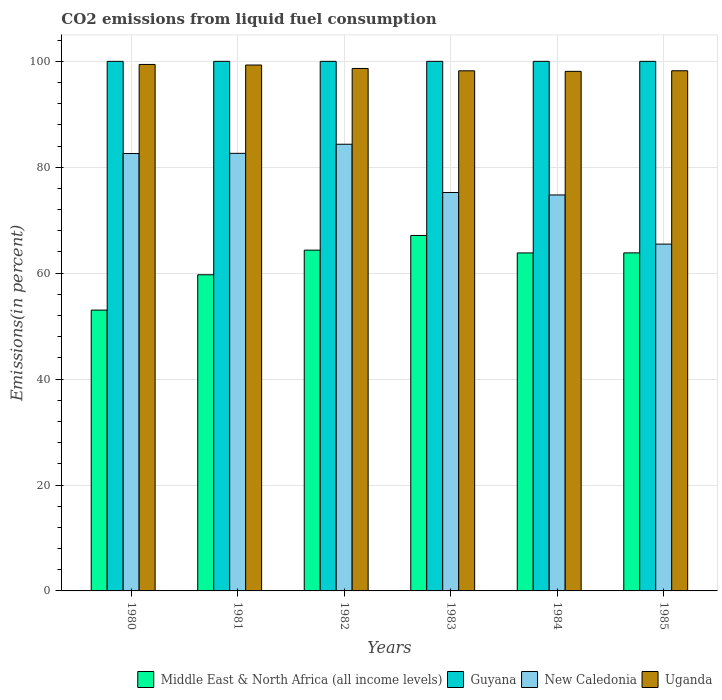Are the number of bars on each tick of the X-axis equal?
Your response must be concise. Yes. How many bars are there on the 5th tick from the left?
Offer a very short reply. 4. What is the label of the 1st group of bars from the left?
Offer a terse response. 1980. What is the total CO2 emitted in Middle East & North Africa (all income levels) in 1984?
Offer a very short reply. 63.83. Across all years, what is the maximum total CO2 emitted in Guyana?
Give a very brief answer. 100. Across all years, what is the minimum total CO2 emitted in Middle East & North Africa (all income levels)?
Offer a very short reply. 53.03. What is the total total CO2 emitted in New Caledonia in the graph?
Your response must be concise. 465.08. What is the difference between the total CO2 emitted in Uganda in 1980 and that in 1982?
Your answer should be very brief. 0.76. What is the difference between the total CO2 emitted in Uganda in 1985 and the total CO2 emitted in New Caledonia in 1980?
Make the answer very short. 15.62. What is the average total CO2 emitted in Uganda per year?
Ensure brevity in your answer.  98.66. In the year 1983, what is the difference between the total CO2 emitted in Middle East & North Africa (all income levels) and total CO2 emitted in Uganda?
Offer a very short reply. -31.09. Is the total CO2 emitted in Guyana in 1983 less than that in 1984?
Provide a succinct answer. No. What is the difference between the highest and the second highest total CO2 emitted in Middle East & North Africa (all income levels)?
Give a very brief answer. 2.77. What is the difference between the highest and the lowest total CO2 emitted in Uganda?
Provide a succinct answer. 1.3. What does the 4th bar from the left in 1983 represents?
Provide a short and direct response. Uganda. What does the 4th bar from the right in 1982 represents?
Ensure brevity in your answer.  Middle East & North Africa (all income levels). How many bars are there?
Ensure brevity in your answer.  24. What is the difference between two consecutive major ticks on the Y-axis?
Your answer should be very brief. 20. Does the graph contain any zero values?
Give a very brief answer. No. Where does the legend appear in the graph?
Provide a succinct answer. Bottom right. What is the title of the graph?
Give a very brief answer. CO2 emissions from liquid fuel consumption. What is the label or title of the Y-axis?
Ensure brevity in your answer.  Emissions(in percent). What is the Emissions(in percent) in Middle East & North Africa (all income levels) in 1980?
Ensure brevity in your answer.  53.03. What is the Emissions(in percent) of Guyana in 1980?
Make the answer very short. 100. What is the Emissions(in percent) of New Caledonia in 1980?
Provide a short and direct response. 82.6. What is the Emissions(in percent) in Uganda in 1980?
Offer a terse response. 99.42. What is the Emissions(in percent) in Middle East & North Africa (all income levels) in 1981?
Keep it short and to the point. 59.7. What is the Emissions(in percent) in Guyana in 1981?
Offer a very short reply. 100. What is the Emissions(in percent) in New Caledonia in 1981?
Your answer should be very brief. 82.63. What is the Emissions(in percent) of Uganda in 1981?
Your answer should be compact. 99.31. What is the Emissions(in percent) of Middle East & North Africa (all income levels) in 1982?
Make the answer very short. 64.35. What is the Emissions(in percent) in Guyana in 1982?
Provide a succinct answer. 100. What is the Emissions(in percent) of New Caledonia in 1982?
Ensure brevity in your answer.  84.35. What is the Emissions(in percent) of Uganda in 1982?
Your response must be concise. 98.66. What is the Emissions(in percent) of Middle East & North Africa (all income levels) in 1983?
Your answer should be compact. 67.12. What is the Emissions(in percent) in New Caledonia in 1983?
Your response must be concise. 75.24. What is the Emissions(in percent) of Uganda in 1983?
Provide a succinct answer. 98.21. What is the Emissions(in percent) in Middle East & North Africa (all income levels) in 1984?
Ensure brevity in your answer.  63.83. What is the Emissions(in percent) in Guyana in 1984?
Offer a very short reply. 100. What is the Emissions(in percent) in New Caledonia in 1984?
Your response must be concise. 74.77. What is the Emissions(in percent) of Uganda in 1984?
Keep it short and to the point. 98.11. What is the Emissions(in percent) in Middle East & North Africa (all income levels) in 1985?
Provide a short and direct response. 63.83. What is the Emissions(in percent) in New Caledonia in 1985?
Give a very brief answer. 65.49. What is the Emissions(in percent) in Uganda in 1985?
Provide a succinct answer. 98.22. Across all years, what is the maximum Emissions(in percent) in Middle East & North Africa (all income levels)?
Your answer should be compact. 67.12. Across all years, what is the maximum Emissions(in percent) of Guyana?
Your answer should be compact. 100. Across all years, what is the maximum Emissions(in percent) in New Caledonia?
Offer a terse response. 84.35. Across all years, what is the maximum Emissions(in percent) of Uganda?
Give a very brief answer. 99.42. Across all years, what is the minimum Emissions(in percent) of Middle East & North Africa (all income levels)?
Make the answer very short. 53.03. Across all years, what is the minimum Emissions(in percent) in New Caledonia?
Ensure brevity in your answer.  65.49. Across all years, what is the minimum Emissions(in percent) of Uganda?
Provide a short and direct response. 98.11. What is the total Emissions(in percent) of Middle East & North Africa (all income levels) in the graph?
Make the answer very short. 371.86. What is the total Emissions(in percent) of Guyana in the graph?
Keep it short and to the point. 600. What is the total Emissions(in percent) of New Caledonia in the graph?
Your answer should be very brief. 465.08. What is the total Emissions(in percent) in Uganda in the graph?
Your answer should be very brief. 591.93. What is the difference between the Emissions(in percent) in Middle East & North Africa (all income levels) in 1980 and that in 1981?
Provide a short and direct response. -6.68. What is the difference between the Emissions(in percent) of Guyana in 1980 and that in 1981?
Your response must be concise. 0. What is the difference between the Emissions(in percent) of New Caledonia in 1980 and that in 1981?
Your answer should be compact. -0.03. What is the difference between the Emissions(in percent) of Uganda in 1980 and that in 1981?
Your response must be concise. 0.11. What is the difference between the Emissions(in percent) in Middle East & North Africa (all income levels) in 1980 and that in 1982?
Make the answer very short. -11.32. What is the difference between the Emissions(in percent) in New Caledonia in 1980 and that in 1982?
Provide a short and direct response. -1.75. What is the difference between the Emissions(in percent) of Uganda in 1980 and that in 1982?
Your response must be concise. 0.76. What is the difference between the Emissions(in percent) in Middle East & North Africa (all income levels) in 1980 and that in 1983?
Offer a very short reply. -14.09. What is the difference between the Emissions(in percent) in New Caledonia in 1980 and that in 1983?
Your answer should be very brief. 7.36. What is the difference between the Emissions(in percent) in Uganda in 1980 and that in 1983?
Keep it short and to the point. 1.2. What is the difference between the Emissions(in percent) in Middle East & North Africa (all income levels) in 1980 and that in 1984?
Offer a very short reply. -10.8. What is the difference between the Emissions(in percent) in Guyana in 1980 and that in 1984?
Your answer should be compact. 0. What is the difference between the Emissions(in percent) of New Caledonia in 1980 and that in 1984?
Give a very brief answer. 7.83. What is the difference between the Emissions(in percent) in Uganda in 1980 and that in 1984?
Your answer should be compact. 1.3. What is the difference between the Emissions(in percent) of Middle East & North Africa (all income levels) in 1980 and that in 1985?
Provide a succinct answer. -10.81. What is the difference between the Emissions(in percent) of New Caledonia in 1980 and that in 1985?
Your answer should be compact. 17.11. What is the difference between the Emissions(in percent) of Uganda in 1980 and that in 1985?
Your answer should be very brief. 1.19. What is the difference between the Emissions(in percent) in Middle East & North Africa (all income levels) in 1981 and that in 1982?
Offer a terse response. -4.65. What is the difference between the Emissions(in percent) in Guyana in 1981 and that in 1982?
Your response must be concise. 0. What is the difference between the Emissions(in percent) of New Caledonia in 1981 and that in 1982?
Keep it short and to the point. -1.72. What is the difference between the Emissions(in percent) in Uganda in 1981 and that in 1982?
Your response must be concise. 0.65. What is the difference between the Emissions(in percent) in Middle East & North Africa (all income levels) in 1981 and that in 1983?
Your answer should be very brief. -7.42. What is the difference between the Emissions(in percent) in New Caledonia in 1981 and that in 1983?
Your response must be concise. 7.39. What is the difference between the Emissions(in percent) of Uganda in 1981 and that in 1983?
Your answer should be very brief. 1.09. What is the difference between the Emissions(in percent) of Middle East & North Africa (all income levels) in 1981 and that in 1984?
Offer a very short reply. -4.12. What is the difference between the Emissions(in percent) in Guyana in 1981 and that in 1984?
Your response must be concise. 0. What is the difference between the Emissions(in percent) in New Caledonia in 1981 and that in 1984?
Your answer should be very brief. 7.86. What is the difference between the Emissions(in percent) in Uganda in 1981 and that in 1984?
Give a very brief answer. 1.19. What is the difference between the Emissions(in percent) in Middle East & North Africa (all income levels) in 1981 and that in 1985?
Provide a succinct answer. -4.13. What is the difference between the Emissions(in percent) in New Caledonia in 1981 and that in 1985?
Give a very brief answer. 17.14. What is the difference between the Emissions(in percent) in Uganda in 1981 and that in 1985?
Make the answer very short. 1.08. What is the difference between the Emissions(in percent) of Middle East & North Africa (all income levels) in 1982 and that in 1983?
Provide a short and direct response. -2.77. What is the difference between the Emissions(in percent) of New Caledonia in 1982 and that in 1983?
Make the answer very short. 9.11. What is the difference between the Emissions(in percent) in Uganda in 1982 and that in 1983?
Your answer should be very brief. 0.44. What is the difference between the Emissions(in percent) of Middle East & North Africa (all income levels) in 1982 and that in 1984?
Provide a short and direct response. 0.52. What is the difference between the Emissions(in percent) in Guyana in 1982 and that in 1984?
Offer a very short reply. 0. What is the difference between the Emissions(in percent) in New Caledonia in 1982 and that in 1984?
Your response must be concise. 9.58. What is the difference between the Emissions(in percent) of Uganda in 1982 and that in 1984?
Give a very brief answer. 0.54. What is the difference between the Emissions(in percent) in Middle East & North Africa (all income levels) in 1982 and that in 1985?
Your answer should be compact. 0.52. What is the difference between the Emissions(in percent) in Guyana in 1982 and that in 1985?
Offer a very short reply. 0. What is the difference between the Emissions(in percent) in New Caledonia in 1982 and that in 1985?
Ensure brevity in your answer.  18.86. What is the difference between the Emissions(in percent) of Uganda in 1982 and that in 1985?
Your response must be concise. 0.43. What is the difference between the Emissions(in percent) of Middle East & North Africa (all income levels) in 1983 and that in 1984?
Your answer should be compact. 3.3. What is the difference between the Emissions(in percent) of New Caledonia in 1983 and that in 1984?
Keep it short and to the point. 0.47. What is the difference between the Emissions(in percent) of Uganda in 1983 and that in 1984?
Your response must be concise. 0.1. What is the difference between the Emissions(in percent) of Middle East & North Africa (all income levels) in 1983 and that in 1985?
Provide a short and direct response. 3.29. What is the difference between the Emissions(in percent) of New Caledonia in 1983 and that in 1985?
Offer a very short reply. 9.75. What is the difference between the Emissions(in percent) of Uganda in 1983 and that in 1985?
Make the answer very short. -0.01. What is the difference between the Emissions(in percent) in Middle East & North Africa (all income levels) in 1984 and that in 1985?
Your answer should be very brief. -0.01. What is the difference between the Emissions(in percent) of New Caledonia in 1984 and that in 1985?
Provide a short and direct response. 9.28. What is the difference between the Emissions(in percent) in Uganda in 1984 and that in 1985?
Offer a very short reply. -0.11. What is the difference between the Emissions(in percent) in Middle East & North Africa (all income levels) in 1980 and the Emissions(in percent) in Guyana in 1981?
Ensure brevity in your answer.  -46.97. What is the difference between the Emissions(in percent) of Middle East & North Africa (all income levels) in 1980 and the Emissions(in percent) of New Caledonia in 1981?
Give a very brief answer. -29.6. What is the difference between the Emissions(in percent) of Middle East & North Africa (all income levels) in 1980 and the Emissions(in percent) of Uganda in 1981?
Offer a very short reply. -46.28. What is the difference between the Emissions(in percent) in Guyana in 1980 and the Emissions(in percent) in New Caledonia in 1981?
Provide a short and direct response. 17.37. What is the difference between the Emissions(in percent) of Guyana in 1980 and the Emissions(in percent) of Uganda in 1981?
Provide a succinct answer. 0.69. What is the difference between the Emissions(in percent) in New Caledonia in 1980 and the Emissions(in percent) in Uganda in 1981?
Offer a very short reply. -16.7. What is the difference between the Emissions(in percent) of Middle East & North Africa (all income levels) in 1980 and the Emissions(in percent) of Guyana in 1982?
Ensure brevity in your answer.  -46.97. What is the difference between the Emissions(in percent) of Middle East & North Africa (all income levels) in 1980 and the Emissions(in percent) of New Caledonia in 1982?
Your response must be concise. -31.32. What is the difference between the Emissions(in percent) in Middle East & North Africa (all income levels) in 1980 and the Emissions(in percent) in Uganda in 1982?
Offer a terse response. -45.63. What is the difference between the Emissions(in percent) in Guyana in 1980 and the Emissions(in percent) in New Caledonia in 1982?
Offer a very short reply. 15.65. What is the difference between the Emissions(in percent) of Guyana in 1980 and the Emissions(in percent) of Uganda in 1982?
Offer a very short reply. 1.34. What is the difference between the Emissions(in percent) in New Caledonia in 1980 and the Emissions(in percent) in Uganda in 1982?
Offer a very short reply. -16.06. What is the difference between the Emissions(in percent) in Middle East & North Africa (all income levels) in 1980 and the Emissions(in percent) in Guyana in 1983?
Keep it short and to the point. -46.97. What is the difference between the Emissions(in percent) of Middle East & North Africa (all income levels) in 1980 and the Emissions(in percent) of New Caledonia in 1983?
Your answer should be very brief. -22.21. What is the difference between the Emissions(in percent) in Middle East & North Africa (all income levels) in 1980 and the Emissions(in percent) in Uganda in 1983?
Make the answer very short. -45.19. What is the difference between the Emissions(in percent) in Guyana in 1980 and the Emissions(in percent) in New Caledonia in 1983?
Offer a very short reply. 24.76. What is the difference between the Emissions(in percent) in Guyana in 1980 and the Emissions(in percent) in Uganda in 1983?
Offer a terse response. 1.79. What is the difference between the Emissions(in percent) in New Caledonia in 1980 and the Emissions(in percent) in Uganda in 1983?
Your response must be concise. -15.61. What is the difference between the Emissions(in percent) of Middle East & North Africa (all income levels) in 1980 and the Emissions(in percent) of Guyana in 1984?
Your answer should be compact. -46.97. What is the difference between the Emissions(in percent) in Middle East & North Africa (all income levels) in 1980 and the Emissions(in percent) in New Caledonia in 1984?
Provide a succinct answer. -21.75. What is the difference between the Emissions(in percent) of Middle East & North Africa (all income levels) in 1980 and the Emissions(in percent) of Uganda in 1984?
Provide a succinct answer. -45.09. What is the difference between the Emissions(in percent) of Guyana in 1980 and the Emissions(in percent) of New Caledonia in 1984?
Offer a very short reply. 25.23. What is the difference between the Emissions(in percent) of Guyana in 1980 and the Emissions(in percent) of Uganda in 1984?
Provide a succinct answer. 1.89. What is the difference between the Emissions(in percent) of New Caledonia in 1980 and the Emissions(in percent) of Uganda in 1984?
Your response must be concise. -15.51. What is the difference between the Emissions(in percent) in Middle East & North Africa (all income levels) in 1980 and the Emissions(in percent) in Guyana in 1985?
Provide a short and direct response. -46.97. What is the difference between the Emissions(in percent) in Middle East & North Africa (all income levels) in 1980 and the Emissions(in percent) in New Caledonia in 1985?
Offer a terse response. -12.46. What is the difference between the Emissions(in percent) of Middle East & North Africa (all income levels) in 1980 and the Emissions(in percent) of Uganda in 1985?
Your answer should be compact. -45.2. What is the difference between the Emissions(in percent) of Guyana in 1980 and the Emissions(in percent) of New Caledonia in 1985?
Keep it short and to the point. 34.51. What is the difference between the Emissions(in percent) in Guyana in 1980 and the Emissions(in percent) in Uganda in 1985?
Make the answer very short. 1.78. What is the difference between the Emissions(in percent) of New Caledonia in 1980 and the Emissions(in percent) of Uganda in 1985?
Your answer should be very brief. -15.62. What is the difference between the Emissions(in percent) in Middle East & North Africa (all income levels) in 1981 and the Emissions(in percent) in Guyana in 1982?
Offer a very short reply. -40.3. What is the difference between the Emissions(in percent) of Middle East & North Africa (all income levels) in 1981 and the Emissions(in percent) of New Caledonia in 1982?
Your answer should be compact. -24.64. What is the difference between the Emissions(in percent) of Middle East & North Africa (all income levels) in 1981 and the Emissions(in percent) of Uganda in 1982?
Make the answer very short. -38.95. What is the difference between the Emissions(in percent) in Guyana in 1981 and the Emissions(in percent) in New Caledonia in 1982?
Your answer should be very brief. 15.65. What is the difference between the Emissions(in percent) of Guyana in 1981 and the Emissions(in percent) of Uganda in 1982?
Give a very brief answer. 1.34. What is the difference between the Emissions(in percent) in New Caledonia in 1981 and the Emissions(in percent) in Uganda in 1982?
Give a very brief answer. -16.03. What is the difference between the Emissions(in percent) in Middle East & North Africa (all income levels) in 1981 and the Emissions(in percent) in Guyana in 1983?
Ensure brevity in your answer.  -40.3. What is the difference between the Emissions(in percent) in Middle East & North Africa (all income levels) in 1981 and the Emissions(in percent) in New Caledonia in 1983?
Keep it short and to the point. -15.54. What is the difference between the Emissions(in percent) of Middle East & North Africa (all income levels) in 1981 and the Emissions(in percent) of Uganda in 1983?
Your answer should be very brief. -38.51. What is the difference between the Emissions(in percent) of Guyana in 1981 and the Emissions(in percent) of New Caledonia in 1983?
Offer a terse response. 24.76. What is the difference between the Emissions(in percent) of Guyana in 1981 and the Emissions(in percent) of Uganda in 1983?
Keep it short and to the point. 1.79. What is the difference between the Emissions(in percent) in New Caledonia in 1981 and the Emissions(in percent) in Uganda in 1983?
Provide a short and direct response. -15.58. What is the difference between the Emissions(in percent) of Middle East & North Africa (all income levels) in 1981 and the Emissions(in percent) of Guyana in 1984?
Ensure brevity in your answer.  -40.3. What is the difference between the Emissions(in percent) of Middle East & North Africa (all income levels) in 1981 and the Emissions(in percent) of New Caledonia in 1984?
Make the answer very short. -15.07. What is the difference between the Emissions(in percent) of Middle East & North Africa (all income levels) in 1981 and the Emissions(in percent) of Uganda in 1984?
Provide a succinct answer. -38.41. What is the difference between the Emissions(in percent) of Guyana in 1981 and the Emissions(in percent) of New Caledonia in 1984?
Offer a very short reply. 25.23. What is the difference between the Emissions(in percent) in Guyana in 1981 and the Emissions(in percent) in Uganda in 1984?
Give a very brief answer. 1.89. What is the difference between the Emissions(in percent) of New Caledonia in 1981 and the Emissions(in percent) of Uganda in 1984?
Offer a very short reply. -15.48. What is the difference between the Emissions(in percent) in Middle East & North Africa (all income levels) in 1981 and the Emissions(in percent) in Guyana in 1985?
Provide a succinct answer. -40.3. What is the difference between the Emissions(in percent) in Middle East & North Africa (all income levels) in 1981 and the Emissions(in percent) in New Caledonia in 1985?
Ensure brevity in your answer.  -5.79. What is the difference between the Emissions(in percent) in Middle East & North Africa (all income levels) in 1981 and the Emissions(in percent) in Uganda in 1985?
Keep it short and to the point. -38.52. What is the difference between the Emissions(in percent) in Guyana in 1981 and the Emissions(in percent) in New Caledonia in 1985?
Your response must be concise. 34.51. What is the difference between the Emissions(in percent) in Guyana in 1981 and the Emissions(in percent) in Uganda in 1985?
Provide a short and direct response. 1.78. What is the difference between the Emissions(in percent) of New Caledonia in 1981 and the Emissions(in percent) of Uganda in 1985?
Provide a succinct answer. -15.59. What is the difference between the Emissions(in percent) of Middle East & North Africa (all income levels) in 1982 and the Emissions(in percent) of Guyana in 1983?
Keep it short and to the point. -35.65. What is the difference between the Emissions(in percent) in Middle East & North Africa (all income levels) in 1982 and the Emissions(in percent) in New Caledonia in 1983?
Keep it short and to the point. -10.89. What is the difference between the Emissions(in percent) of Middle East & North Africa (all income levels) in 1982 and the Emissions(in percent) of Uganda in 1983?
Offer a very short reply. -33.87. What is the difference between the Emissions(in percent) in Guyana in 1982 and the Emissions(in percent) in New Caledonia in 1983?
Give a very brief answer. 24.76. What is the difference between the Emissions(in percent) in Guyana in 1982 and the Emissions(in percent) in Uganda in 1983?
Provide a succinct answer. 1.79. What is the difference between the Emissions(in percent) of New Caledonia in 1982 and the Emissions(in percent) of Uganda in 1983?
Your response must be concise. -13.87. What is the difference between the Emissions(in percent) of Middle East & North Africa (all income levels) in 1982 and the Emissions(in percent) of Guyana in 1984?
Make the answer very short. -35.65. What is the difference between the Emissions(in percent) in Middle East & North Africa (all income levels) in 1982 and the Emissions(in percent) in New Caledonia in 1984?
Your answer should be compact. -10.42. What is the difference between the Emissions(in percent) of Middle East & North Africa (all income levels) in 1982 and the Emissions(in percent) of Uganda in 1984?
Ensure brevity in your answer.  -33.76. What is the difference between the Emissions(in percent) in Guyana in 1982 and the Emissions(in percent) in New Caledonia in 1984?
Your answer should be compact. 25.23. What is the difference between the Emissions(in percent) in Guyana in 1982 and the Emissions(in percent) in Uganda in 1984?
Make the answer very short. 1.89. What is the difference between the Emissions(in percent) in New Caledonia in 1982 and the Emissions(in percent) in Uganda in 1984?
Your answer should be very brief. -13.77. What is the difference between the Emissions(in percent) of Middle East & North Africa (all income levels) in 1982 and the Emissions(in percent) of Guyana in 1985?
Your answer should be compact. -35.65. What is the difference between the Emissions(in percent) of Middle East & North Africa (all income levels) in 1982 and the Emissions(in percent) of New Caledonia in 1985?
Your answer should be very brief. -1.14. What is the difference between the Emissions(in percent) in Middle East & North Africa (all income levels) in 1982 and the Emissions(in percent) in Uganda in 1985?
Make the answer very short. -33.88. What is the difference between the Emissions(in percent) of Guyana in 1982 and the Emissions(in percent) of New Caledonia in 1985?
Ensure brevity in your answer.  34.51. What is the difference between the Emissions(in percent) in Guyana in 1982 and the Emissions(in percent) in Uganda in 1985?
Provide a succinct answer. 1.78. What is the difference between the Emissions(in percent) in New Caledonia in 1982 and the Emissions(in percent) in Uganda in 1985?
Keep it short and to the point. -13.88. What is the difference between the Emissions(in percent) of Middle East & North Africa (all income levels) in 1983 and the Emissions(in percent) of Guyana in 1984?
Provide a succinct answer. -32.88. What is the difference between the Emissions(in percent) of Middle East & North Africa (all income levels) in 1983 and the Emissions(in percent) of New Caledonia in 1984?
Make the answer very short. -7.65. What is the difference between the Emissions(in percent) of Middle East & North Africa (all income levels) in 1983 and the Emissions(in percent) of Uganda in 1984?
Make the answer very short. -30.99. What is the difference between the Emissions(in percent) in Guyana in 1983 and the Emissions(in percent) in New Caledonia in 1984?
Offer a terse response. 25.23. What is the difference between the Emissions(in percent) of Guyana in 1983 and the Emissions(in percent) of Uganda in 1984?
Give a very brief answer. 1.89. What is the difference between the Emissions(in percent) of New Caledonia in 1983 and the Emissions(in percent) of Uganda in 1984?
Provide a succinct answer. -22.88. What is the difference between the Emissions(in percent) of Middle East & North Africa (all income levels) in 1983 and the Emissions(in percent) of Guyana in 1985?
Offer a terse response. -32.88. What is the difference between the Emissions(in percent) of Middle East & North Africa (all income levels) in 1983 and the Emissions(in percent) of New Caledonia in 1985?
Provide a short and direct response. 1.63. What is the difference between the Emissions(in percent) of Middle East & North Africa (all income levels) in 1983 and the Emissions(in percent) of Uganda in 1985?
Your answer should be compact. -31.1. What is the difference between the Emissions(in percent) in Guyana in 1983 and the Emissions(in percent) in New Caledonia in 1985?
Give a very brief answer. 34.51. What is the difference between the Emissions(in percent) of Guyana in 1983 and the Emissions(in percent) of Uganda in 1985?
Keep it short and to the point. 1.78. What is the difference between the Emissions(in percent) in New Caledonia in 1983 and the Emissions(in percent) in Uganda in 1985?
Your answer should be compact. -22.99. What is the difference between the Emissions(in percent) in Middle East & North Africa (all income levels) in 1984 and the Emissions(in percent) in Guyana in 1985?
Offer a very short reply. -36.17. What is the difference between the Emissions(in percent) in Middle East & North Africa (all income levels) in 1984 and the Emissions(in percent) in New Caledonia in 1985?
Ensure brevity in your answer.  -1.67. What is the difference between the Emissions(in percent) in Middle East & North Africa (all income levels) in 1984 and the Emissions(in percent) in Uganda in 1985?
Provide a short and direct response. -34.4. What is the difference between the Emissions(in percent) in Guyana in 1984 and the Emissions(in percent) in New Caledonia in 1985?
Make the answer very short. 34.51. What is the difference between the Emissions(in percent) of Guyana in 1984 and the Emissions(in percent) of Uganda in 1985?
Provide a succinct answer. 1.78. What is the difference between the Emissions(in percent) in New Caledonia in 1984 and the Emissions(in percent) in Uganda in 1985?
Keep it short and to the point. -23.45. What is the average Emissions(in percent) in Middle East & North Africa (all income levels) per year?
Give a very brief answer. 61.98. What is the average Emissions(in percent) of Guyana per year?
Keep it short and to the point. 100. What is the average Emissions(in percent) in New Caledonia per year?
Your response must be concise. 77.51. What is the average Emissions(in percent) in Uganda per year?
Ensure brevity in your answer.  98.66. In the year 1980, what is the difference between the Emissions(in percent) in Middle East & North Africa (all income levels) and Emissions(in percent) in Guyana?
Your answer should be very brief. -46.97. In the year 1980, what is the difference between the Emissions(in percent) in Middle East & North Africa (all income levels) and Emissions(in percent) in New Caledonia?
Keep it short and to the point. -29.57. In the year 1980, what is the difference between the Emissions(in percent) of Middle East & North Africa (all income levels) and Emissions(in percent) of Uganda?
Offer a very short reply. -46.39. In the year 1980, what is the difference between the Emissions(in percent) in Guyana and Emissions(in percent) in New Caledonia?
Give a very brief answer. 17.4. In the year 1980, what is the difference between the Emissions(in percent) in Guyana and Emissions(in percent) in Uganda?
Keep it short and to the point. 0.58. In the year 1980, what is the difference between the Emissions(in percent) in New Caledonia and Emissions(in percent) in Uganda?
Your response must be concise. -16.81. In the year 1981, what is the difference between the Emissions(in percent) of Middle East & North Africa (all income levels) and Emissions(in percent) of Guyana?
Offer a very short reply. -40.3. In the year 1981, what is the difference between the Emissions(in percent) of Middle East & North Africa (all income levels) and Emissions(in percent) of New Caledonia?
Ensure brevity in your answer.  -22.93. In the year 1981, what is the difference between the Emissions(in percent) in Middle East & North Africa (all income levels) and Emissions(in percent) in Uganda?
Give a very brief answer. -39.6. In the year 1981, what is the difference between the Emissions(in percent) of Guyana and Emissions(in percent) of New Caledonia?
Provide a succinct answer. 17.37. In the year 1981, what is the difference between the Emissions(in percent) of Guyana and Emissions(in percent) of Uganda?
Your answer should be very brief. 0.69. In the year 1981, what is the difference between the Emissions(in percent) in New Caledonia and Emissions(in percent) in Uganda?
Ensure brevity in your answer.  -16.67. In the year 1982, what is the difference between the Emissions(in percent) of Middle East & North Africa (all income levels) and Emissions(in percent) of Guyana?
Your answer should be compact. -35.65. In the year 1982, what is the difference between the Emissions(in percent) of Middle East & North Africa (all income levels) and Emissions(in percent) of New Caledonia?
Provide a short and direct response. -20. In the year 1982, what is the difference between the Emissions(in percent) of Middle East & North Africa (all income levels) and Emissions(in percent) of Uganda?
Give a very brief answer. -34.31. In the year 1982, what is the difference between the Emissions(in percent) in Guyana and Emissions(in percent) in New Caledonia?
Your answer should be compact. 15.65. In the year 1982, what is the difference between the Emissions(in percent) in Guyana and Emissions(in percent) in Uganda?
Your response must be concise. 1.34. In the year 1982, what is the difference between the Emissions(in percent) in New Caledonia and Emissions(in percent) in Uganda?
Keep it short and to the point. -14.31. In the year 1983, what is the difference between the Emissions(in percent) of Middle East & North Africa (all income levels) and Emissions(in percent) of Guyana?
Provide a short and direct response. -32.88. In the year 1983, what is the difference between the Emissions(in percent) in Middle East & North Africa (all income levels) and Emissions(in percent) in New Caledonia?
Your answer should be very brief. -8.12. In the year 1983, what is the difference between the Emissions(in percent) of Middle East & North Africa (all income levels) and Emissions(in percent) of Uganda?
Your response must be concise. -31.09. In the year 1983, what is the difference between the Emissions(in percent) of Guyana and Emissions(in percent) of New Caledonia?
Make the answer very short. 24.76. In the year 1983, what is the difference between the Emissions(in percent) of Guyana and Emissions(in percent) of Uganda?
Your answer should be very brief. 1.79. In the year 1983, what is the difference between the Emissions(in percent) in New Caledonia and Emissions(in percent) in Uganda?
Your answer should be compact. -22.98. In the year 1984, what is the difference between the Emissions(in percent) of Middle East & North Africa (all income levels) and Emissions(in percent) of Guyana?
Make the answer very short. -36.17. In the year 1984, what is the difference between the Emissions(in percent) of Middle East & North Africa (all income levels) and Emissions(in percent) of New Caledonia?
Keep it short and to the point. -10.95. In the year 1984, what is the difference between the Emissions(in percent) of Middle East & North Africa (all income levels) and Emissions(in percent) of Uganda?
Offer a terse response. -34.29. In the year 1984, what is the difference between the Emissions(in percent) of Guyana and Emissions(in percent) of New Caledonia?
Your answer should be very brief. 25.23. In the year 1984, what is the difference between the Emissions(in percent) in Guyana and Emissions(in percent) in Uganda?
Your answer should be very brief. 1.89. In the year 1984, what is the difference between the Emissions(in percent) in New Caledonia and Emissions(in percent) in Uganda?
Provide a short and direct response. -23.34. In the year 1985, what is the difference between the Emissions(in percent) of Middle East & North Africa (all income levels) and Emissions(in percent) of Guyana?
Ensure brevity in your answer.  -36.17. In the year 1985, what is the difference between the Emissions(in percent) in Middle East & North Africa (all income levels) and Emissions(in percent) in New Caledonia?
Give a very brief answer. -1.66. In the year 1985, what is the difference between the Emissions(in percent) of Middle East & North Africa (all income levels) and Emissions(in percent) of Uganda?
Your response must be concise. -34.39. In the year 1985, what is the difference between the Emissions(in percent) in Guyana and Emissions(in percent) in New Caledonia?
Your answer should be very brief. 34.51. In the year 1985, what is the difference between the Emissions(in percent) in Guyana and Emissions(in percent) in Uganda?
Make the answer very short. 1.78. In the year 1985, what is the difference between the Emissions(in percent) in New Caledonia and Emissions(in percent) in Uganda?
Give a very brief answer. -32.73. What is the ratio of the Emissions(in percent) of Middle East & North Africa (all income levels) in 1980 to that in 1981?
Give a very brief answer. 0.89. What is the ratio of the Emissions(in percent) in Middle East & North Africa (all income levels) in 1980 to that in 1982?
Your response must be concise. 0.82. What is the ratio of the Emissions(in percent) in New Caledonia in 1980 to that in 1982?
Give a very brief answer. 0.98. What is the ratio of the Emissions(in percent) in Uganda in 1980 to that in 1982?
Give a very brief answer. 1.01. What is the ratio of the Emissions(in percent) of Middle East & North Africa (all income levels) in 1980 to that in 1983?
Give a very brief answer. 0.79. What is the ratio of the Emissions(in percent) in Guyana in 1980 to that in 1983?
Provide a succinct answer. 1. What is the ratio of the Emissions(in percent) in New Caledonia in 1980 to that in 1983?
Your answer should be very brief. 1.1. What is the ratio of the Emissions(in percent) of Uganda in 1980 to that in 1983?
Offer a terse response. 1.01. What is the ratio of the Emissions(in percent) of Middle East & North Africa (all income levels) in 1980 to that in 1984?
Ensure brevity in your answer.  0.83. What is the ratio of the Emissions(in percent) in Guyana in 1980 to that in 1984?
Offer a terse response. 1. What is the ratio of the Emissions(in percent) in New Caledonia in 1980 to that in 1984?
Keep it short and to the point. 1.1. What is the ratio of the Emissions(in percent) of Uganda in 1980 to that in 1984?
Offer a very short reply. 1.01. What is the ratio of the Emissions(in percent) of Middle East & North Africa (all income levels) in 1980 to that in 1985?
Your answer should be very brief. 0.83. What is the ratio of the Emissions(in percent) in New Caledonia in 1980 to that in 1985?
Provide a succinct answer. 1.26. What is the ratio of the Emissions(in percent) in Uganda in 1980 to that in 1985?
Offer a terse response. 1.01. What is the ratio of the Emissions(in percent) of Middle East & North Africa (all income levels) in 1981 to that in 1982?
Keep it short and to the point. 0.93. What is the ratio of the Emissions(in percent) of New Caledonia in 1981 to that in 1982?
Your response must be concise. 0.98. What is the ratio of the Emissions(in percent) in Uganda in 1981 to that in 1982?
Give a very brief answer. 1.01. What is the ratio of the Emissions(in percent) in Middle East & North Africa (all income levels) in 1981 to that in 1983?
Offer a terse response. 0.89. What is the ratio of the Emissions(in percent) of New Caledonia in 1981 to that in 1983?
Give a very brief answer. 1.1. What is the ratio of the Emissions(in percent) of Uganda in 1981 to that in 1983?
Make the answer very short. 1.01. What is the ratio of the Emissions(in percent) of Middle East & North Africa (all income levels) in 1981 to that in 1984?
Provide a succinct answer. 0.94. What is the ratio of the Emissions(in percent) in New Caledonia in 1981 to that in 1984?
Keep it short and to the point. 1.11. What is the ratio of the Emissions(in percent) of Uganda in 1981 to that in 1984?
Give a very brief answer. 1.01. What is the ratio of the Emissions(in percent) in Middle East & North Africa (all income levels) in 1981 to that in 1985?
Make the answer very short. 0.94. What is the ratio of the Emissions(in percent) in New Caledonia in 1981 to that in 1985?
Your response must be concise. 1.26. What is the ratio of the Emissions(in percent) in Uganda in 1981 to that in 1985?
Keep it short and to the point. 1.01. What is the ratio of the Emissions(in percent) of Middle East & North Africa (all income levels) in 1982 to that in 1983?
Your answer should be very brief. 0.96. What is the ratio of the Emissions(in percent) in New Caledonia in 1982 to that in 1983?
Make the answer very short. 1.12. What is the ratio of the Emissions(in percent) of Uganda in 1982 to that in 1983?
Your answer should be very brief. 1. What is the ratio of the Emissions(in percent) of Middle East & North Africa (all income levels) in 1982 to that in 1984?
Provide a short and direct response. 1.01. What is the ratio of the Emissions(in percent) of New Caledonia in 1982 to that in 1984?
Offer a very short reply. 1.13. What is the ratio of the Emissions(in percent) of Guyana in 1982 to that in 1985?
Ensure brevity in your answer.  1. What is the ratio of the Emissions(in percent) of New Caledonia in 1982 to that in 1985?
Your answer should be compact. 1.29. What is the ratio of the Emissions(in percent) in Middle East & North Africa (all income levels) in 1983 to that in 1984?
Offer a terse response. 1.05. What is the ratio of the Emissions(in percent) of New Caledonia in 1983 to that in 1984?
Your answer should be very brief. 1.01. What is the ratio of the Emissions(in percent) in Middle East & North Africa (all income levels) in 1983 to that in 1985?
Your answer should be compact. 1.05. What is the ratio of the Emissions(in percent) of New Caledonia in 1983 to that in 1985?
Your answer should be compact. 1.15. What is the ratio of the Emissions(in percent) of Uganda in 1983 to that in 1985?
Make the answer very short. 1. What is the ratio of the Emissions(in percent) in Middle East & North Africa (all income levels) in 1984 to that in 1985?
Offer a terse response. 1. What is the ratio of the Emissions(in percent) of New Caledonia in 1984 to that in 1985?
Make the answer very short. 1.14. What is the ratio of the Emissions(in percent) of Uganda in 1984 to that in 1985?
Your response must be concise. 1. What is the difference between the highest and the second highest Emissions(in percent) of Middle East & North Africa (all income levels)?
Your response must be concise. 2.77. What is the difference between the highest and the second highest Emissions(in percent) of Guyana?
Offer a very short reply. 0. What is the difference between the highest and the second highest Emissions(in percent) of New Caledonia?
Give a very brief answer. 1.72. What is the difference between the highest and the second highest Emissions(in percent) of Uganda?
Give a very brief answer. 0.11. What is the difference between the highest and the lowest Emissions(in percent) in Middle East & North Africa (all income levels)?
Your answer should be very brief. 14.09. What is the difference between the highest and the lowest Emissions(in percent) of Guyana?
Give a very brief answer. 0. What is the difference between the highest and the lowest Emissions(in percent) of New Caledonia?
Provide a short and direct response. 18.86. What is the difference between the highest and the lowest Emissions(in percent) of Uganda?
Provide a short and direct response. 1.3. 